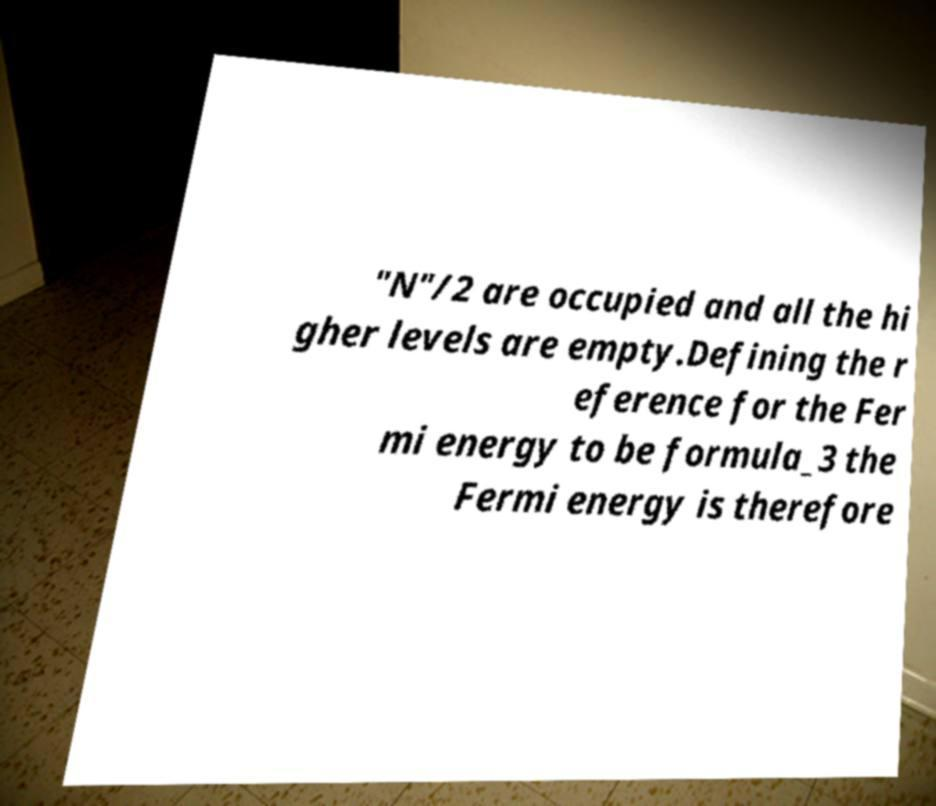Please identify and transcribe the text found in this image. "N"/2 are occupied and all the hi gher levels are empty.Defining the r eference for the Fer mi energy to be formula_3 the Fermi energy is therefore 